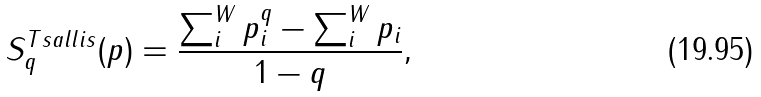Convert formula to latex. <formula><loc_0><loc_0><loc_500><loc_500>S _ { q } ^ { T s a l l i s } ( p ) = \frac { \sum _ { i } ^ { W } p _ { i } ^ { q } - \sum _ { i } ^ { W } p _ { i } } { 1 - q } ,</formula> 